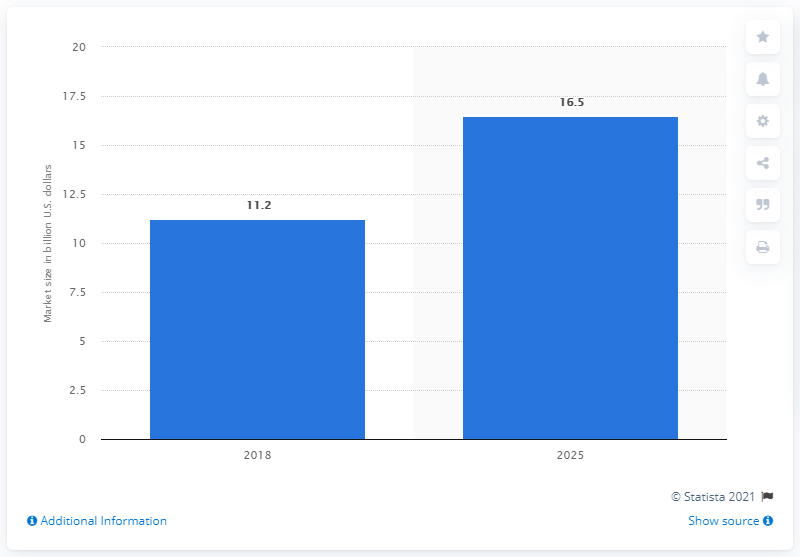Indicate a few pertinent items in this graphic. The forecast for the medical x-ray industry in 2025 is expected to be strong. The global medical x-ray market was valued at approximately $11.2 billion in 2018. According to estimates, the global medical X-ray market was valued at approximately 16.5 by 2025. 